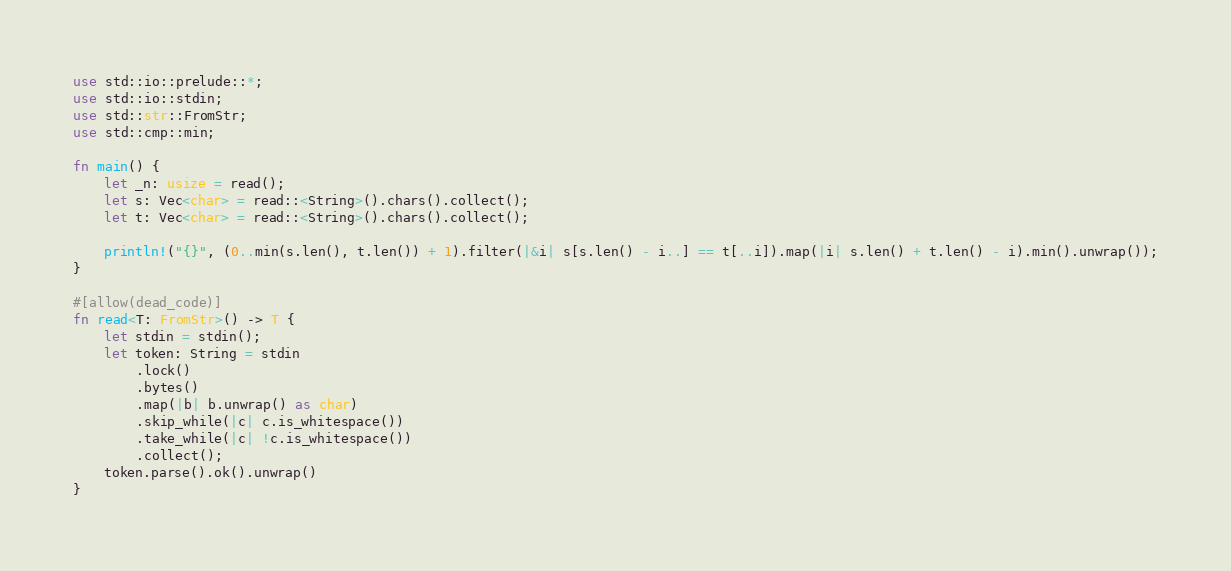Convert code to text. <code><loc_0><loc_0><loc_500><loc_500><_Rust_>use std::io::prelude::*;
use std::io::stdin;
use std::str::FromStr;
use std::cmp::min;

fn main() {
    let _n: usize = read();
    let s: Vec<char> = read::<String>().chars().collect();
    let t: Vec<char> = read::<String>().chars().collect();

    println!("{}", (0..min(s.len(), t.len()) + 1).filter(|&i| s[s.len() - i..] == t[..i]).map(|i| s.len() + t.len() - i).min().unwrap());
}

#[allow(dead_code)]
fn read<T: FromStr>() -> T {
    let stdin = stdin();
    let token: String = stdin
        .lock()
        .bytes()
        .map(|b| b.unwrap() as char)
        .skip_while(|c| c.is_whitespace())
        .take_while(|c| !c.is_whitespace())
        .collect();
    token.parse().ok().unwrap()
}
</code> 